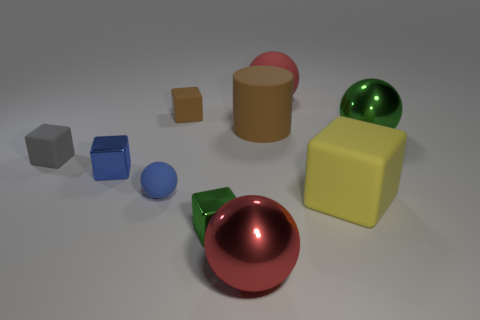Subtract all green metallic cubes. How many cubes are left? 4 Subtract all green spheres. How many spheres are left? 3 Subtract all yellow cylinders. How many red spheres are left? 2 Subtract 1 yellow cubes. How many objects are left? 9 Subtract all spheres. How many objects are left? 6 Subtract 1 cubes. How many cubes are left? 4 Subtract all yellow cubes. Subtract all yellow cylinders. How many cubes are left? 4 Subtract all green cubes. Subtract all small matte blocks. How many objects are left? 7 Add 3 small blue shiny things. How many small blue shiny things are left? 4 Add 8 large metal things. How many large metal things exist? 10 